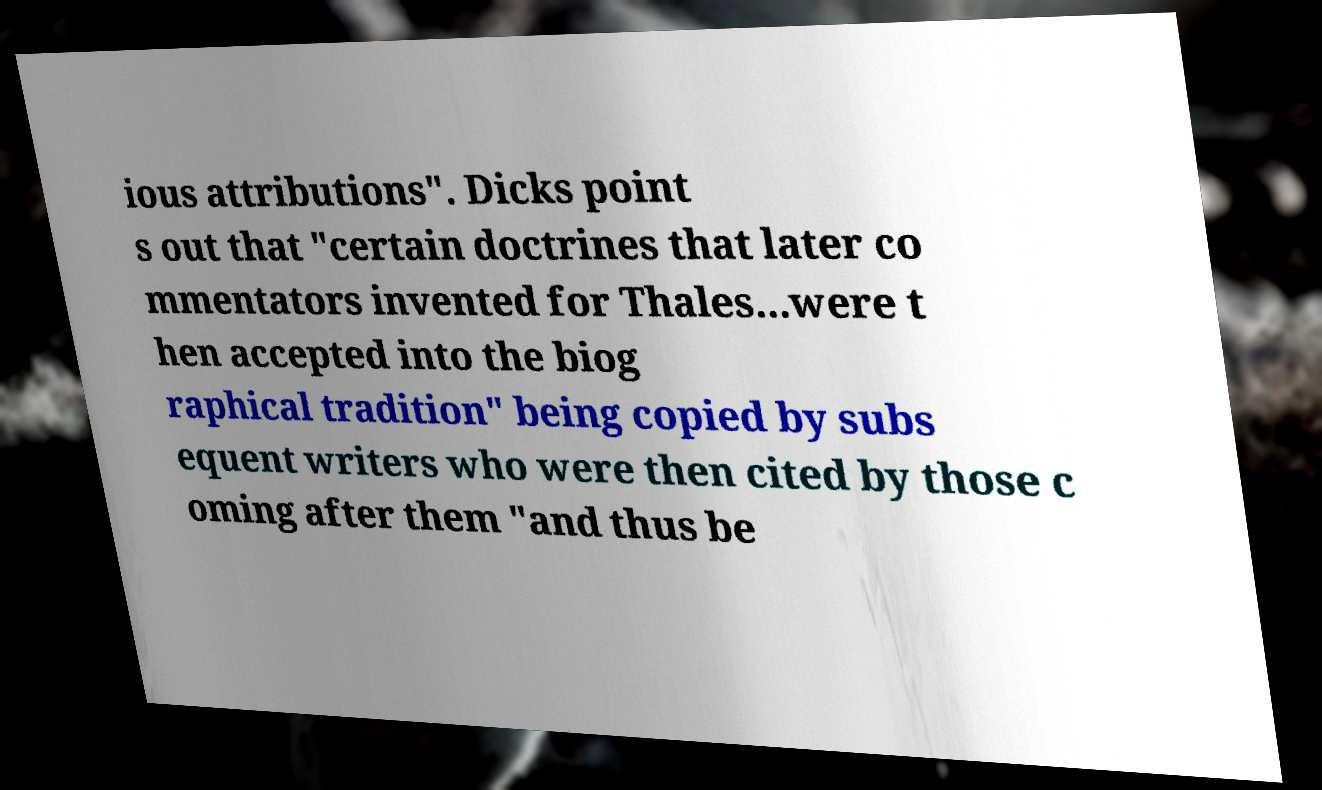Can you read and provide the text displayed in the image?This photo seems to have some interesting text. Can you extract and type it out for me? ious attributions". Dicks point s out that "certain doctrines that later co mmentators invented for Thales...were t hen accepted into the biog raphical tradition" being copied by subs equent writers who were then cited by those c oming after them "and thus be 